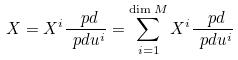<formula> <loc_0><loc_0><loc_500><loc_500>X = X ^ { i } \frac { \ p d } { \ p d u ^ { i } } = \sum _ { i = 1 } ^ { \dim M } X ^ { i } \frac { \ p d } { \ p d u ^ { i } }</formula> 